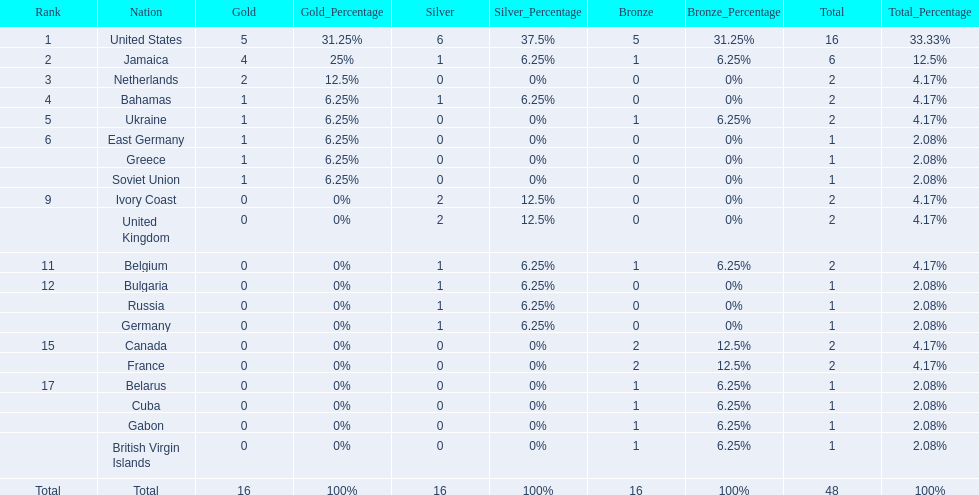After the united states, what country won the most gold medals. Jamaica. 